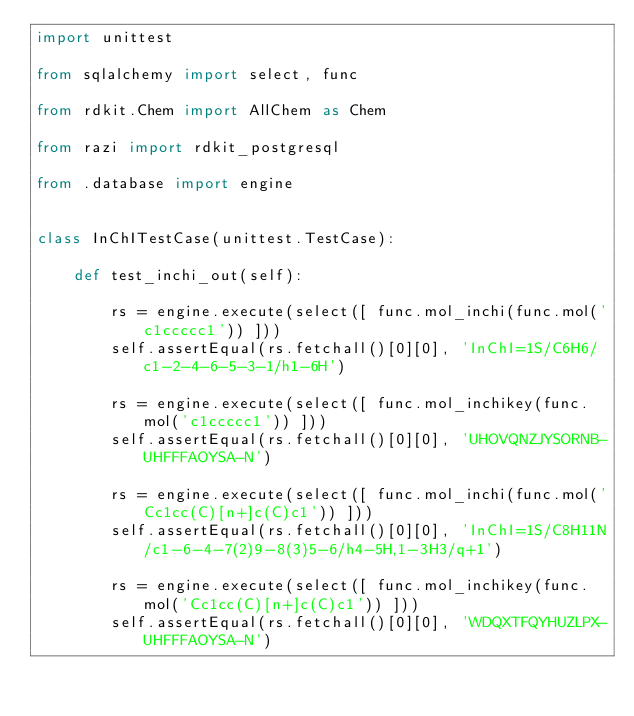<code> <loc_0><loc_0><loc_500><loc_500><_Python_>import unittest

from sqlalchemy import select, func

from rdkit.Chem import AllChem as Chem

from razi import rdkit_postgresql

from .database import engine


class InChITestCase(unittest.TestCase):

    def test_inchi_out(self):

        rs = engine.execute(select([ func.mol_inchi(func.mol('c1ccccc1')) ]))
        self.assertEqual(rs.fetchall()[0][0], 'InChI=1S/C6H6/c1-2-4-6-5-3-1/h1-6H')

        rs = engine.execute(select([ func.mol_inchikey(func.mol('c1ccccc1')) ]))
        self.assertEqual(rs.fetchall()[0][0], 'UHOVQNZJYSORNB-UHFFFAOYSA-N')

        rs = engine.execute(select([ func.mol_inchi(func.mol('Cc1cc(C)[n+]c(C)c1')) ]))
        self.assertEqual(rs.fetchall()[0][0], 'InChI=1S/C8H11N/c1-6-4-7(2)9-8(3)5-6/h4-5H,1-3H3/q+1')

        rs = engine.execute(select([ func.mol_inchikey(func.mol('Cc1cc(C)[n+]c(C)c1')) ]))
        self.assertEqual(rs.fetchall()[0][0], 'WDQXTFQYHUZLPX-UHFFFAOYSA-N')
</code> 